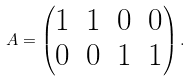Convert formula to latex. <formula><loc_0><loc_0><loc_500><loc_500>A = \begin{pmatrix} 1 & 1 & 0 & 0 \\ 0 & 0 & 1 & 1 \end{pmatrix} .</formula> 